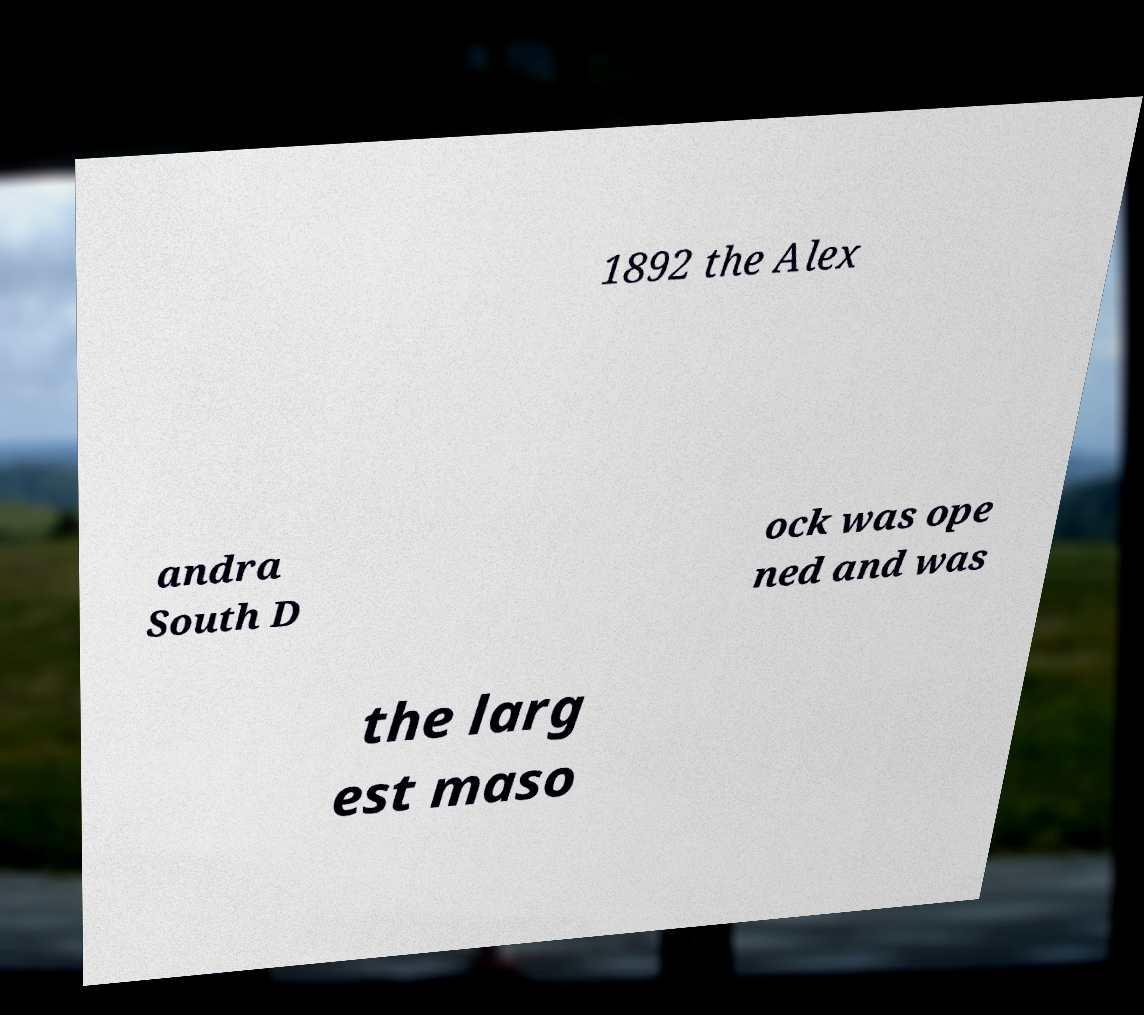There's text embedded in this image that I need extracted. Can you transcribe it verbatim? 1892 the Alex andra South D ock was ope ned and was the larg est maso 